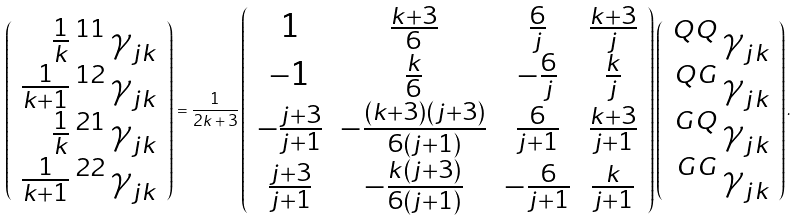Convert formula to latex. <formula><loc_0><loc_0><loc_500><loc_500>\left ( \begin{array} { r } \frac { 1 } { k } \, { ^ { 1 1 } \, \gamma } _ { j k } \\ \frac { 1 } { k + 1 } \, { ^ { 1 2 } \, \gamma } _ { j k } \\ \frac { 1 } { k } \, { ^ { 2 1 } \, \gamma } _ { j k } \\ \frac { 1 } { k + 1 } \, { ^ { 2 2 } \, \gamma } _ { j k } \end{array} \right ) = \frac { 1 } { 2 k + 3 } \left ( \begin{array} { c c c c } 1 & \frac { k + 3 } { 6 } & \frac { 6 } { j } & \frac { k + 3 } { j } \\ - 1 & \frac { k } { 6 } & - \frac { 6 } { j } & \frac { k } { j } \\ - \frac { j + 3 } { j + 1 } & - \frac { ( k + 3 ) ( j + 3 ) } { 6 ( j + 1 ) } & \frac { 6 } { j + 1 } & \frac { k + 3 } { j + 1 } \\ \frac { j + 3 } { j + 1 } & - \frac { k ( j + 3 ) } { 6 ( j + 1 ) } & - \frac { 6 } { j + 1 } & \frac { k } { j + 1 } \end{array} \right ) \left ( \begin{array} { r } { ^ { Q Q } \, \gamma } _ { j k } \\ { ^ { Q G } \, \gamma } _ { j k } \\ { ^ { G Q } \, \gamma } _ { j k } \\ { ^ { G G } \, \gamma } _ { j k } \end{array} \right ) .</formula> 